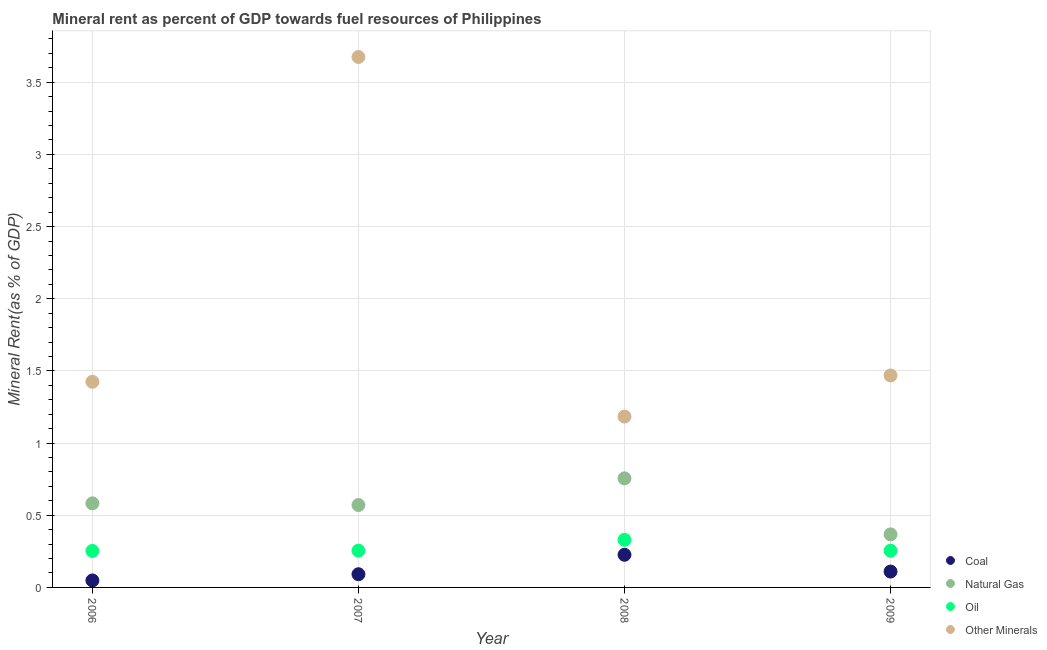How many different coloured dotlines are there?
Provide a succinct answer. 4. What is the oil rent in 2009?
Ensure brevity in your answer.  0.25. Across all years, what is the maximum natural gas rent?
Keep it short and to the point. 0.76. Across all years, what is the minimum oil rent?
Make the answer very short. 0.25. What is the total natural gas rent in the graph?
Your response must be concise. 2.28. What is the difference between the natural gas rent in 2007 and that in 2008?
Provide a succinct answer. -0.18. What is the difference between the coal rent in 2006 and the natural gas rent in 2008?
Provide a short and direct response. -0.71. What is the average natural gas rent per year?
Your response must be concise. 0.57. In the year 2007, what is the difference between the natural gas rent and coal rent?
Provide a short and direct response. 0.48. In how many years, is the natural gas rent greater than 3.5 %?
Make the answer very short. 0. What is the ratio of the  rent of other minerals in 2007 to that in 2008?
Offer a very short reply. 3.1. Is the coal rent in 2007 less than that in 2009?
Offer a terse response. Yes. Is the difference between the  rent of other minerals in 2008 and 2009 greater than the difference between the oil rent in 2008 and 2009?
Ensure brevity in your answer.  No. What is the difference between the highest and the second highest oil rent?
Ensure brevity in your answer.  0.07. What is the difference between the highest and the lowest  rent of other minerals?
Provide a short and direct response. 2.49. In how many years, is the oil rent greater than the average oil rent taken over all years?
Offer a very short reply. 1. Is the sum of the coal rent in 2006 and 2007 greater than the maximum  rent of other minerals across all years?
Provide a short and direct response. No. Is it the case that in every year, the sum of the natural gas rent and oil rent is greater than the sum of coal rent and  rent of other minerals?
Give a very brief answer. Yes. Is it the case that in every year, the sum of the coal rent and natural gas rent is greater than the oil rent?
Provide a short and direct response. Yes. Is the coal rent strictly greater than the  rent of other minerals over the years?
Your answer should be very brief. No. Is the natural gas rent strictly less than the oil rent over the years?
Offer a terse response. No. How many years are there in the graph?
Your answer should be very brief. 4. Does the graph contain any zero values?
Your answer should be compact. No. Does the graph contain grids?
Your response must be concise. Yes. How many legend labels are there?
Your response must be concise. 4. How are the legend labels stacked?
Your answer should be compact. Vertical. What is the title of the graph?
Make the answer very short. Mineral rent as percent of GDP towards fuel resources of Philippines. What is the label or title of the Y-axis?
Make the answer very short. Mineral Rent(as % of GDP). What is the Mineral Rent(as % of GDP) of Coal in 2006?
Your response must be concise. 0.05. What is the Mineral Rent(as % of GDP) in Natural Gas in 2006?
Offer a terse response. 0.58. What is the Mineral Rent(as % of GDP) in Oil in 2006?
Your response must be concise. 0.25. What is the Mineral Rent(as % of GDP) of Other Minerals in 2006?
Ensure brevity in your answer.  1.42. What is the Mineral Rent(as % of GDP) in Coal in 2007?
Your answer should be very brief. 0.09. What is the Mineral Rent(as % of GDP) in Natural Gas in 2007?
Offer a very short reply. 0.57. What is the Mineral Rent(as % of GDP) in Oil in 2007?
Give a very brief answer. 0.25. What is the Mineral Rent(as % of GDP) in Other Minerals in 2007?
Offer a terse response. 3.67. What is the Mineral Rent(as % of GDP) in Coal in 2008?
Your answer should be compact. 0.23. What is the Mineral Rent(as % of GDP) in Natural Gas in 2008?
Keep it short and to the point. 0.76. What is the Mineral Rent(as % of GDP) in Oil in 2008?
Give a very brief answer. 0.33. What is the Mineral Rent(as % of GDP) of Other Minerals in 2008?
Offer a very short reply. 1.18. What is the Mineral Rent(as % of GDP) in Coal in 2009?
Offer a terse response. 0.11. What is the Mineral Rent(as % of GDP) in Natural Gas in 2009?
Offer a terse response. 0.37. What is the Mineral Rent(as % of GDP) in Oil in 2009?
Ensure brevity in your answer.  0.25. What is the Mineral Rent(as % of GDP) of Other Minerals in 2009?
Make the answer very short. 1.47. Across all years, what is the maximum Mineral Rent(as % of GDP) of Coal?
Make the answer very short. 0.23. Across all years, what is the maximum Mineral Rent(as % of GDP) in Natural Gas?
Your response must be concise. 0.76. Across all years, what is the maximum Mineral Rent(as % of GDP) of Oil?
Your answer should be compact. 0.33. Across all years, what is the maximum Mineral Rent(as % of GDP) of Other Minerals?
Make the answer very short. 3.67. Across all years, what is the minimum Mineral Rent(as % of GDP) in Coal?
Your answer should be compact. 0.05. Across all years, what is the minimum Mineral Rent(as % of GDP) in Natural Gas?
Ensure brevity in your answer.  0.37. Across all years, what is the minimum Mineral Rent(as % of GDP) in Oil?
Provide a short and direct response. 0.25. Across all years, what is the minimum Mineral Rent(as % of GDP) in Other Minerals?
Provide a short and direct response. 1.18. What is the total Mineral Rent(as % of GDP) of Coal in the graph?
Provide a succinct answer. 0.48. What is the total Mineral Rent(as % of GDP) in Natural Gas in the graph?
Keep it short and to the point. 2.28. What is the total Mineral Rent(as % of GDP) of Oil in the graph?
Give a very brief answer. 1.09. What is the total Mineral Rent(as % of GDP) in Other Minerals in the graph?
Give a very brief answer. 7.75. What is the difference between the Mineral Rent(as % of GDP) in Coal in 2006 and that in 2007?
Provide a short and direct response. -0.04. What is the difference between the Mineral Rent(as % of GDP) of Natural Gas in 2006 and that in 2007?
Provide a short and direct response. 0.01. What is the difference between the Mineral Rent(as % of GDP) in Oil in 2006 and that in 2007?
Keep it short and to the point. -0. What is the difference between the Mineral Rent(as % of GDP) in Other Minerals in 2006 and that in 2007?
Ensure brevity in your answer.  -2.25. What is the difference between the Mineral Rent(as % of GDP) in Coal in 2006 and that in 2008?
Your answer should be compact. -0.18. What is the difference between the Mineral Rent(as % of GDP) of Natural Gas in 2006 and that in 2008?
Ensure brevity in your answer.  -0.17. What is the difference between the Mineral Rent(as % of GDP) in Oil in 2006 and that in 2008?
Your response must be concise. -0.08. What is the difference between the Mineral Rent(as % of GDP) in Other Minerals in 2006 and that in 2008?
Give a very brief answer. 0.24. What is the difference between the Mineral Rent(as % of GDP) in Coal in 2006 and that in 2009?
Your answer should be compact. -0.06. What is the difference between the Mineral Rent(as % of GDP) of Natural Gas in 2006 and that in 2009?
Your answer should be compact. 0.21. What is the difference between the Mineral Rent(as % of GDP) of Oil in 2006 and that in 2009?
Keep it short and to the point. -0. What is the difference between the Mineral Rent(as % of GDP) of Other Minerals in 2006 and that in 2009?
Ensure brevity in your answer.  -0.04. What is the difference between the Mineral Rent(as % of GDP) of Coal in 2007 and that in 2008?
Give a very brief answer. -0.13. What is the difference between the Mineral Rent(as % of GDP) of Natural Gas in 2007 and that in 2008?
Provide a succinct answer. -0.18. What is the difference between the Mineral Rent(as % of GDP) of Oil in 2007 and that in 2008?
Your answer should be compact. -0.07. What is the difference between the Mineral Rent(as % of GDP) of Other Minerals in 2007 and that in 2008?
Offer a terse response. 2.49. What is the difference between the Mineral Rent(as % of GDP) of Coal in 2007 and that in 2009?
Give a very brief answer. -0.02. What is the difference between the Mineral Rent(as % of GDP) of Natural Gas in 2007 and that in 2009?
Provide a succinct answer. 0.2. What is the difference between the Mineral Rent(as % of GDP) of Oil in 2007 and that in 2009?
Give a very brief answer. 0. What is the difference between the Mineral Rent(as % of GDP) in Other Minerals in 2007 and that in 2009?
Your response must be concise. 2.21. What is the difference between the Mineral Rent(as % of GDP) of Coal in 2008 and that in 2009?
Provide a succinct answer. 0.12. What is the difference between the Mineral Rent(as % of GDP) of Natural Gas in 2008 and that in 2009?
Your answer should be very brief. 0.39. What is the difference between the Mineral Rent(as % of GDP) in Oil in 2008 and that in 2009?
Keep it short and to the point. 0.08. What is the difference between the Mineral Rent(as % of GDP) in Other Minerals in 2008 and that in 2009?
Your response must be concise. -0.28. What is the difference between the Mineral Rent(as % of GDP) in Coal in 2006 and the Mineral Rent(as % of GDP) in Natural Gas in 2007?
Provide a succinct answer. -0.52. What is the difference between the Mineral Rent(as % of GDP) of Coal in 2006 and the Mineral Rent(as % of GDP) of Oil in 2007?
Your response must be concise. -0.21. What is the difference between the Mineral Rent(as % of GDP) of Coal in 2006 and the Mineral Rent(as % of GDP) of Other Minerals in 2007?
Give a very brief answer. -3.63. What is the difference between the Mineral Rent(as % of GDP) of Natural Gas in 2006 and the Mineral Rent(as % of GDP) of Oil in 2007?
Keep it short and to the point. 0.33. What is the difference between the Mineral Rent(as % of GDP) of Natural Gas in 2006 and the Mineral Rent(as % of GDP) of Other Minerals in 2007?
Keep it short and to the point. -3.09. What is the difference between the Mineral Rent(as % of GDP) of Oil in 2006 and the Mineral Rent(as % of GDP) of Other Minerals in 2007?
Your response must be concise. -3.42. What is the difference between the Mineral Rent(as % of GDP) in Coal in 2006 and the Mineral Rent(as % of GDP) in Natural Gas in 2008?
Ensure brevity in your answer.  -0.71. What is the difference between the Mineral Rent(as % of GDP) of Coal in 2006 and the Mineral Rent(as % of GDP) of Oil in 2008?
Your answer should be compact. -0.28. What is the difference between the Mineral Rent(as % of GDP) of Coal in 2006 and the Mineral Rent(as % of GDP) of Other Minerals in 2008?
Your answer should be compact. -1.14. What is the difference between the Mineral Rent(as % of GDP) in Natural Gas in 2006 and the Mineral Rent(as % of GDP) in Oil in 2008?
Give a very brief answer. 0.25. What is the difference between the Mineral Rent(as % of GDP) of Natural Gas in 2006 and the Mineral Rent(as % of GDP) of Other Minerals in 2008?
Make the answer very short. -0.6. What is the difference between the Mineral Rent(as % of GDP) of Oil in 2006 and the Mineral Rent(as % of GDP) of Other Minerals in 2008?
Your answer should be compact. -0.93. What is the difference between the Mineral Rent(as % of GDP) of Coal in 2006 and the Mineral Rent(as % of GDP) of Natural Gas in 2009?
Provide a short and direct response. -0.32. What is the difference between the Mineral Rent(as % of GDP) in Coal in 2006 and the Mineral Rent(as % of GDP) in Oil in 2009?
Offer a very short reply. -0.21. What is the difference between the Mineral Rent(as % of GDP) in Coal in 2006 and the Mineral Rent(as % of GDP) in Other Minerals in 2009?
Provide a short and direct response. -1.42. What is the difference between the Mineral Rent(as % of GDP) in Natural Gas in 2006 and the Mineral Rent(as % of GDP) in Oil in 2009?
Offer a terse response. 0.33. What is the difference between the Mineral Rent(as % of GDP) of Natural Gas in 2006 and the Mineral Rent(as % of GDP) of Other Minerals in 2009?
Make the answer very short. -0.89. What is the difference between the Mineral Rent(as % of GDP) in Oil in 2006 and the Mineral Rent(as % of GDP) in Other Minerals in 2009?
Ensure brevity in your answer.  -1.22. What is the difference between the Mineral Rent(as % of GDP) in Coal in 2007 and the Mineral Rent(as % of GDP) in Natural Gas in 2008?
Your response must be concise. -0.66. What is the difference between the Mineral Rent(as % of GDP) of Coal in 2007 and the Mineral Rent(as % of GDP) of Oil in 2008?
Ensure brevity in your answer.  -0.24. What is the difference between the Mineral Rent(as % of GDP) of Coal in 2007 and the Mineral Rent(as % of GDP) of Other Minerals in 2008?
Make the answer very short. -1.09. What is the difference between the Mineral Rent(as % of GDP) in Natural Gas in 2007 and the Mineral Rent(as % of GDP) in Oil in 2008?
Make the answer very short. 0.24. What is the difference between the Mineral Rent(as % of GDP) of Natural Gas in 2007 and the Mineral Rent(as % of GDP) of Other Minerals in 2008?
Make the answer very short. -0.61. What is the difference between the Mineral Rent(as % of GDP) of Oil in 2007 and the Mineral Rent(as % of GDP) of Other Minerals in 2008?
Give a very brief answer. -0.93. What is the difference between the Mineral Rent(as % of GDP) in Coal in 2007 and the Mineral Rent(as % of GDP) in Natural Gas in 2009?
Your response must be concise. -0.28. What is the difference between the Mineral Rent(as % of GDP) in Coal in 2007 and the Mineral Rent(as % of GDP) in Oil in 2009?
Your answer should be very brief. -0.16. What is the difference between the Mineral Rent(as % of GDP) in Coal in 2007 and the Mineral Rent(as % of GDP) in Other Minerals in 2009?
Offer a terse response. -1.38. What is the difference between the Mineral Rent(as % of GDP) of Natural Gas in 2007 and the Mineral Rent(as % of GDP) of Oil in 2009?
Your answer should be compact. 0.32. What is the difference between the Mineral Rent(as % of GDP) of Natural Gas in 2007 and the Mineral Rent(as % of GDP) of Other Minerals in 2009?
Offer a very short reply. -0.9. What is the difference between the Mineral Rent(as % of GDP) in Oil in 2007 and the Mineral Rent(as % of GDP) in Other Minerals in 2009?
Offer a terse response. -1.21. What is the difference between the Mineral Rent(as % of GDP) of Coal in 2008 and the Mineral Rent(as % of GDP) of Natural Gas in 2009?
Ensure brevity in your answer.  -0.14. What is the difference between the Mineral Rent(as % of GDP) of Coal in 2008 and the Mineral Rent(as % of GDP) of Oil in 2009?
Offer a very short reply. -0.03. What is the difference between the Mineral Rent(as % of GDP) in Coal in 2008 and the Mineral Rent(as % of GDP) in Other Minerals in 2009?
Ensure brevity in your answer.  -1.24. What is the difference between the Mineral Rent(as % of GDP) of Natural Gas in 2008 and the Mineral Rent(as % of GDP) of Oil in 2009?
Your answer should be very brief. 0.5. What is the difference between the Mineral Rent(as % of GDP) in Natural Gas in 2008 and the Mineral Rent(as % of GDP) in Other Minerals in 2009?
Offer a terse response. -0.71. What is the difference between the Mineral Rent(as % of GDP) of Oil in 2008 and the Mineral Rent(as % of GDP) of Other Minerals in 2009?
Ensure brevity in your answer.  -1.14. What is the average Mineral Rent(as % of GDP) in Coal per year?
Your response must be concise. 0.12. What is the average Mineral Rent(as % of GDP) in Natural Gas per year?
Make the answer very short. 0.57. What is the average Mineral Rent(as % of GDP) in Oil per year?
Keep it short and to the point. 0.27. What is the average Mineral Rent(as % of GDP) in Other Minerals per year?
Your response must be concise. 1.94. In the year 2006, what is the difference between the Mineral Rent(as % of GDP) in Coal and Mineral Rent(as % of GDP) in Natural Gas?
Your answer should be compact. -0.53. In the year 2006, what is the difference between the Mineral Rent(as % of GDP) of Coal and Mineral Rent(as % of GDP) of Oil?
Your answer should be compact. -0.2. In the year 2006, what is the difference between the Mineral Rent(as % of GDP) of Coal and Mineral Rent(as % of GDP) of Other Minerals?
Provide a succinct answer. -1.38. In the year 2006, what is the difference between the Mineral Rent(as % of GDP) in Natural Gas and Mineral Rent(as % of GDP) in Oil?
Your answer should be very brief. 0.33. In the year 2006, what is the difference between the Mineral Rent(as % of GDP) of Natural Gas and Mineral Rent(as % of GDP) of Other Minerals?
Make the answer very short. -0.84. In the year 2006, what is the difference between the Mineral Rent(as % of GDP) of Oil and Mineral Rent(as % of GDP) of Other Minerals?
Give a very brief answer. -1.17. In the year 2007, what is the difference between the Mineral Rent(as % of GDP) of Coal and Mineral Rent(as % of GDP) of Natural Gas?
Your answer should be very brief. -0.48. In the year 2007, what is the difference between the Mineral Rent(as % of GDP) of Coal and Mineral Rent(as % of GDP) of Oil?
Keep it short and to the point. -0.16. In the year 2007, what is the difference between the Mineral Rent(as % of GDP) of Coal and Mineral Rent(as % of GDP) of Other Minerals?
Make the answer very short. -3.58. In the year 2007, what is the difference between the Mineral Rent(as % of GDP) of Natural Gas and Mineral Rent(as % of GDP) of Oil?
Your answer should be very brief. 0.32. In the year 2007, what is the difference between the Mineral Rent(as % of GDP) in Natural Gas and Mineral Rent(as % of GDP) in Other Minerals?
Ensure brevity in your answer.  -3.1. In the year 2007, what is the difference between the Mineral Rent(as % of GDP) of Oil and Mineral Rent(as % of GDP) of Other Minerals?
Your response must be concise. -3.42. In the year 2008, what is the difference between the Mineral Rent(as % of GDP) of Coal and Mineral Rent(as % of GDP) of Natural Gas?
Make the answer very short. -0.53. In the year 2008, what is the difference between the Mineral Rent(as % of GDP) in Coal and Mineral Rent(as % of GDP) in Oil?
Offer a very short reply. -0.1. In the year 2008, what is the difference between the Mineral Rent(as % of GDP) of Coal and Mineral Rent(as % of GDP) of Other Minerals?
Your answer should be very brief. -0.96. In the year 2008, what is the difference between the Mineral Rent(as % of GDP) of Natural Gas and Mineral Rent(as % of GDP) of Oil?
Your answer should be compact. 0.43. In the year 2008, what is the difference between the Mineral Rent(as % of GDP) in Natural Gas and Mineral Rent(as % of GDP) in Other Minerals?
Provide a short and direct response. -0.43. In the year 2008, what is the difference between the Mineral Rent(as % of GDP) of Oil and Mineral Rent(as % of GDP) of Other Minerals?
Offer a very short reply. -0.85. In the year 2009, what is the difference between the Mineral Rent(as % of GDP) in Coal and Mineral Rent(as % of GDP) in Natural Gas?
Make the answer very short. -0.26. In the year 2009, what is the difference between the Mineral Rent(as % of GDP) in Coal and Mineral Rent(as % of GDP) in Oil?
Provide a succinct answer. -0.14. In the year 2009, what is the difference between the Mineral Rent(as % of GDP) of Coal and Mineral Rent(as % of GDP) of Other Minerals?
Ensure brevity in your answer.  -1.36. In the year 2009, what is the difference between the Mineral Rent(as % of GDP) of Natural Gas and Mineral Rent(as % of GDP) of Oil?
Provide a short and direct response. 0.11. In the year 2009, what is the difference between the Mineral Rent(as % of GDP) in Natural Gas and Mineral Rent(as % of GDP) in Other Minerals?
Your answer should be compact. -1.1. In the year 2009, what is the difference between the Mineral Rent(as % of GDP) of Oil and Mineral Rent(as % of GDP) of Other Minerals?
Provide a succinct answer. -1.21. What is the ratio of the Mineral Rent(as % of GDP) in Coal in 2006 to that in 2007?
Offer a very short reply. 0.53. What is the ratio of the Mineral Rent(as % of GDP) of Natural Gas in 2006 to that in 2007?
Your response must be concise. 1.02. What is the ratio of the Mineral Rent(as % of GDP) of Oil in 2006 to that in 2007?
Ensure brevity in your answer.  0.99. What is the ratio of the Mineral Rent(as % of GDP) in Other Minerals in 2006 to that in 2007?
Your answer should be very brief. 0.39. What is the ratio of the Mineral Rent(as % of GDP) in Coal in 2006 to that in 2008?
Offer a very short reply. 0.21. What is the ratio of the Mineral Rent(as % of GDP) of Natural Gas in 2006 to that in 2008?
Provide a short and direct response. 0.77. What is the ratio of the Mineral Rent(as % of GDP) of Oil in 2006 to that in 2008?
Provide a short and direct response. 0.77. What is the ratio of the Mineral Rent(as % of GDP) in Other Minerals in 2006 to that in 2008?
Offer a very short reply. 1.2. What is the ratio of the Mineral Rent(as % of GDP) in Coal in 2006 to that in 2009?
Offer a very short reply. 0.44. What is the ratio of the Mineral Rent(as % of GDP) of Natural Gas in 2006 to that in 2009?
Ensure brevity in your answer.  1.58. What is the ratio of the Mineral Rent(as % of GDP) in Other Minerals in 2006 to that in 2009?
Make the answer very short. 0.97. What is the ratio of the Mineral Rent(as % of GDP) of Coal in 2007 to that in 2008?
Keep it short and to the point. 0.4. What is the ratio of the Mineral Rent(as % of GDP) of Natural Gas in 2007 to that in 2008?
Make the answer very short. 0.76. What is the ratio of the Mineral Rent(as % of GDP) of Oil in 2007 to that in 2008?
Provide a short and direct response. 0.77. What is the ratio of the Mineral Rent(as % of GDP) of Other Minerals in 2007 to that in 2008?
Keep it short and to the point. 3.1. What is the ratio of the Mineral Rent(as % of GDP) of Coal in 2007 to that in 2009?
Ensure brevity in your answer.  0.83. What is the ratio of the Mineral Rent(as % of GDP) in Natural Gas in 2007 to that in 2009?
Ensure brevity in your answer.  1.55. What is the ratio of the Mineral Rent(as % of GDP) of Other Minerals in 2007 to that in 2009?
Provide a short and direct response. 2.5. What is the ratio of the Mineral Rent(as % of GDP) of Coal in 2008 to that in 2009?
Your response must be concise. 2.06. What is the ratio of the Mineral Rent(as % of GDP) of Natural Gas in 2008 to that in 2009?
Your answer should be compact. 2.06. What is the ratio of the Mineral Rent(as % of GDP) in Oil in 2008 to that in 2009?
Provide a succinct answer. 1.3. What is the ratio of the Mineral Rent(as % of GDP) of Other Minerals in 2008 to that in 2009?
Make the answer very short. 0.81. What is the difference between the highest and the second highest Mineral Rent(as % of GDP) in Coal?
Ensure brevity in your answer.  0.12. What is the difference between the highest and the second highest Mineral Rent(as % of GDP) of Natural Gas?
Ensure brevity in your answer.  0.17. What is the difference between the highest and the second highest Mineral Rent(as % of GDP) in Oil?
Keep it short and to the point. 0.07. What is the difference between the highest and the second highest Mineral Rent(as % of GDP) in Other Minerals?
Offer a very short reply. 2.21. What is the difference between the highest and the lowest Mineral Rent(as % of GDP) of Coal?
Offer a terse response. 0.18. What is the difference between the highest and the lowest Mineral Rent(as % of GDP) in Natural Gas?
Provide a short and direct response. 0.39. What is the difference between the highest and the lowest Mineral Rent(as % of GDP) in Oil?
Offer a very short reply. 0.08. What is the difference between the highest and the lowest Mineral Rent(as % of GDP) of Other Minerals?
Your response must be concise. 2.49. 